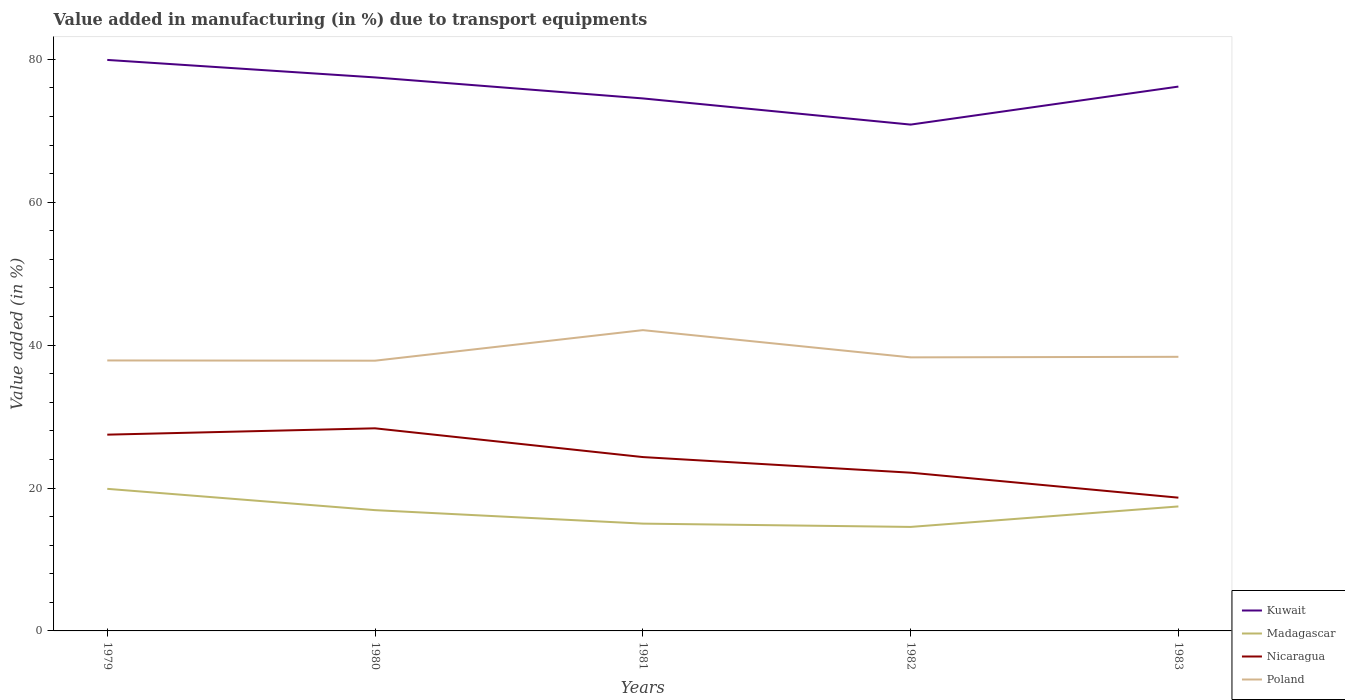How many different coloured lines are there?
Your response must be concise. 4. Across all years, what is the maximum percentage of value added in manufacturing due to transport equipments in Madagascar?
Provide a succinct answer. 14.55. In which year was the percentage of value added in manufacturing due to transport equipments in Kuwait maximum?
Keep it short and to the point. 1982. What is the total percentage of value added in manufacturing due to transport equipments in Poland in the graph?
Give a very brief answer. -0.08. What is the difference between the highest and the second highest percentage of value added in manufacturing due to transport equipments in Poland?
Make the answer very short. 4.28. How many lines are there?
Your answer should be very brief. 4. Are the values on the major ticks of Y-axis written in scientific E-notation?
Provide a short and direct response. No. Does the graph contain any zero values?
Ensure brevity in your answer.  No. Does the graph contain grids?
Make the answer very short. No. How many legend labels are there?
Your answer should be very brief. 4. What is the title of the graph?
Your response must be concise. Value added in manufacturing (in %) due to transport equipments. What is the label or title of the Y-axis?
Your answer should be compact. Value added (in %). What is the Value added (in %) in Kuwait in 1979?
Offer a very short reply. 79.91. What is the Value added (in %) in Madagascar in 1979?
Your answer should be compact. 19.88. What is the Value added (in %) of Nicaragua in 1979?
Provide a succinct answer. 27.47. What is the Value added (in %) in Poland in 1979?
Provide a succinct answer. 37.85. What is the Value added (in %) in Kuwait in 1980?
Provide a succinct answer. 77.46. What is the Value added (in %) in Madagascar in 1980?
Make the answer very short. 16.9. What is the Value added (in %) of Nicaragua in 1980?
Give a very brief answer. 28.35. What is the Value added (in %) of Poland in 1980?
Provide a short and direct response. 37.82. What is the Value added (in %) in Kuwait in 1981?
Your answer should be very brief. 74.52. What is the Value added (in %) of Madagascar in 1981?
Give a very brief answer. 15.01. What is the Value added (in %) in Nicaragua in 1981?
Provide a succinct answer. 24.33. What is the Value added (in %) in Poland in 1981?
Your answer should be very brief. 42.09. What is the Value added (in %) of Kuwait in 1982?
Your answer should be compact. 70.86. What is the Value added (in %) in Madagascar in 1982?
Your response must be concise. 14.55. What is the Value added (in %) in Nicaragua in 1982?
Offer a very short reply. 22.14. What is the Value added (in %) in Poland in 1982?
Make the answer very short. 38.28. What is the Value added (in %) in Kuwait in 1983?
Make the answer very short. 76.18. What is the Value added (in %) in Madagascar in 1983?
Offer a terse response. 17.42. What is the Value added (in %) in Nicaragua in 1983?
Provide a succinct answer. 18.65. What is the Value added (in %) of Poland in 1983?
Give a very brief answer. 38.36. Across all years, what is the maximum Value added (in %) of Kuwait?
Keep it short and to the point. 79.91. Across all years, what is the maximum Value added (in %) of Madagascar?
Your answer should be very brief. 19.88. Across all years, what is the maximum Value added (in %) in Nicaragua?
Your answer should be very brief. 28.35. Across all years, what is the maximum Value added (in %) in Poland?
Your response must be concise. 42.09. Across all years, what is the minimum Value added (in %) in Kuwait?
Your response must be concise. 70.86. Across all years, what is the minimum Value added (in %) of Madagascar?
Give a very brief answer. 14.55. Across all years, what is the minimum Value added (in %) of Nicaragua?
Offer a terse response. 18.65. Across all years, what is the minimum Value added (in %) in Poland?
Keep it short and to the point. 37.82. What is the total Value added (in %) of Kuwait in the graph?
Offer a terse response. 378.92. What is the total Value added (in %) in Madagascar in the graph?
Provide a short and direct response. 83.78. What is the total Value added (in %) in Nicaragua in the graph?
Your response must be concise. 120.94. What is the total Value added (in %) in Poland in the graph?
Keep it short and to the point. 194.4. What is the difference between the Value added (in %) in Kuwait in 1979 and that in 1980?
Provide a succinct answer. 2.45. What is the difference between the Value added (in %) in Madagascar in 1979 and that in 1980?
Give a very brief answer. 2.98. What is the difference between the Value added (in %) of Nicaragua in 1979 and that in 1980?
Ensure brevity in your answer.  -0.89. What is the difference between the Value added (in %) in Poland in 1979 and that in 1980?
Your answer should be very brief. 0.03. What is the difference between the Value added (in %) in Kuwait in 1979 and that in 1981?
Your answer should be very brief. 5.39. What is the difference between the Value added (in %) in Madagascar in 1979 and that in 1981?
Provide a succinct answer. 4.87. What is the difference between the Value added (in %) of Nicaragua in 1979 and that in 1981?
Your answer should be very brief. 3.14. What is the difference between the Value added (in %) of Poland in 1979 and that in 1981?
Ensure brevity in your answer.  -4.24. What is the difference between the Value added (in %) in Kuwait in 1979 and that in 1982?
Your response must be concise. 9.05. What is the difference between the Value added (in %) of Madagascar in 1979 and that in 1982?
Ensure brevity in your answer.  5.33. What is the difference between the Value added (in %) in Nicaragua in 1979 and that in 1982?
Give a very brief answer. 5.32. What is the difference between the Value added (in %) in Poland in 1979 and that in 1982?
Your response must be concise. -0.43. What is the difference between the Value added (in %) of Kuwait in 1979 and that in 1983?
Offer a terse response. 3.73. What is the difference between the Value added (in %) in Madagascar in 1979 and that in 1983?
Your answer should be very brief. 2.46. What is the difference between the Value added (in %) in Nicaragua in 1979 and that in 1983?
Your answer should be compact. 8.82. What is the difference between the Value added (in %) of Poland in 1979 and that in 1983?
Your answer should be compact. -0.51. What is the difference between the Value added (in %) in Kuwait in 1980 and that in 1981?
Your answer should be very brief. 2.94. What is the difference between the Value added (in %) of Madagascar in 1980 and that in 1981?
Keep it short and to the point. 1.89. What is the difference between the Value added (in %) in Nicaragua in 1980 and that in 1981?
Your answer should be compact. 4.02. What is the difference between the Value added (in %) of Poland in 1980 and that in 1981?
Offer a very short reply. -4.28. What is the difference between the Value added (in %) of Kuwait in 1980 and that in 1982?
Your answer should be very brief. 6.6. What is the difference between the Value added (in %) in Madagascar in 1980 and that in 1982?
Your response must be concise. 2.35. What is the difference between the Value added (in %) in Nicaragua in 1980 and that in 1982?
Offer a very short reply. 6.21. What is the difference between the Value added (in %) in Poland in 1980 and that in 1982?
Keep it short and to the point. -0.47. What is the difference between the Value added (in %) in Kuwait in 1980 and that in 1983?
Offer a terse response. 1.28. What is the difference between the Value added (in %) in Madagascar in 1980 and that in 1983?
Your response must be concise. -0.52. What is the difference between the Value added (in %) in Nicaragua in 1980 and that in 1983?
Your answer should be compact. 9.7. What is the difference between the Value added (in %) in Poland in 1980 and that in 1983?
Ensure brevity in your answer.  -0.54. What is the difference between the Value added (in %) of Kuwait in 1981 and that in 1982?
Offer a terse response. 3.66. What is the difference between the Value added (in %) in Madagascar in 1981 and that in 1982?
Your response must be concise. 0.46. What is the difference between the Value added (in %) in Nicaragua in 1981 and that in 1982?
Provide a succinct answer. 2.19. What is the difference between the Value added (in %) in Poland in 1981 and that in 1982?
Ensure brevity in your answer.  3.81. What is the difference between the Value added (in %) in Kuwait in 1981 and that in 1983?
Your response must be concise. -1.66. What is the difference between the Value added (in %) in Madagascar in 1981 and that in 1983?
Offer a very short reply. -2.41. What is the difference between the Value added (in %) in Nicaragua in 1981 and that in 1983?
Offer a terse response. 5.68. What is the difference between the Value added (in %) of Poland in 1981 and that in 1983?
Your answer should be very brief. 3.73. What is the difference between the Value added (in %) of Kuwait in 1982 and that in 1983?
Offer a very short reply. -5.32. What is the difference between the Value added (in %) of Madagascar in 1982 and that in 1983?
Your answer should be compact. -2.87. What is the difference between the Value added (in %) in Nicaragua in 1982 and that in 1983?
Keep it short and to the point. 3.5. What is the difference between the Value added (in %) of Poland in 1982 and that in 1983?
Make the answer very short. -0.08. What is the difference between the Value added (in %) of Kuwait in 1979 and the Value added (in %) of Madagascar in 1980?
Provide a succinct answer. 63. What is the difference between the Value added (in %) in Kuwait in 1979 and the Value added (in %) in Nicaragua in 1980?
Give a very brief answer. 51.55. What is the difference between the Value added (in %) of Kuwait in 1979 and the Value added (in %) of Poland in 1980?
Give a very brief answer. 42.09. What is the difference between the Value added (in %) of Madagascar in 1979 and the Value added (in %) of Nicaragua in 1980?
Keep it short and to the point. -8.47. What is the difference between the Value added (in %) in Madagascar in 1979 and the Value added (in %) in Poland in 1980?
Your answer should be very brief. -17.93. What is the difference between the Value added (in %) of Nicaragua in 1979 and the Value added (in %) of Poland in 1980?
Offer a very short reply. -10.35. What is the difference between the Value added (in %) of Kuwait in 1979 and the Value added (in %) of Madagascar in 1981?
Your response must be concise. 64.89. What is the difference between the Value added (in %) in Kuwait in 1979 and the Value added (in %) in Nicaragua in 1981?
Provide a short and direct response. 55.58. What is the difference between the Value added (in %) in Kuwait in 1979 and the Value added (in %) in Poland in 1981?
Provide a succinct answer. 37.81. What is the difference between the Value added (in %) of Madagascar in 1979 and the Value added (in %) of Nicaragua in 1981?
Offer a terse response. -4.45. What is the difference between the Value added (in %) in Madagascar in 1979 and the Value added (in %) in Poland in 1981?
Offer a very short reply. -22.21. What is the difference between the Value added (in %) of Nicaragua in 1979 and the Value added (in %) of Poland in 1981?
Keep it short and to the point. -14.63. What is the difference between the Value added (in %) of Kuwait in 1979 and the Value added (in %) of Madagascar in 1982?
Make the answer very short. 65.35. What is the difference between the Value added (in %) of Kuwait in 1979 and the Value added (in %) of Nicaragua in 1982?
Provide a short and direct response. 57.76. What is the difference between the Value added (in %) of Kuwait in 1979 and the Value added (in %) of Poland in 1982?
Your answer should be compact. 41.62. What is the difference between the Value added (in %) of Madagascar in 1979 and the Value added (in %) of Nicaragua in 1982?
Your answer should be very brief. -2.26. What is the difference between the Value added (in %) in Madagascar in 1979 and the Value added (in %) in Poland in 1982?
Offer a terse response. -18.4. What is the difference between the Value added (in %) of Nicaragua in 1979 and the Value added (in %) of Poland in 1982?
Give a very brief answer. -10.82. What is the difference between the Value added (in %) in Kuwait in 1979 and the Value added (in %) in Madagascar in 1983?
Your answer should be very brief. 62.49. What is the difference between the Value added (in %) of Kuwait in 1979 and the Value added (in %) of Nicaragua in 1983?
Your answer should be very brief. 61.26. What is the difference between the Value added (in %) of Kuwait in 1979 and the Value added (in %) of Poland in 1983?
Make the answer very short. 41.55. What is the difference between the Value added (in %) of Madagascar in 1979 and the Value added (in %) of Nicaragua in 1983?
Your answer should be very brief. 1.23. What is the difference between the Value added (in %) of Madagascar in 1979 and the Value added (in %) of Poland in 1983?
Make the answer very short. -18.48. What is the difference between the Value added (in %) of Nicaragua in 1979 and the Value added (in %) of Poland in 1983?
Provide a succinct answer. -10.89. What is the difference between the Value added (in %) in Kuwait in 1980 and the Value added (in %) in Madagascar in 1981?
Your answer should be compact. 62.44. What is the difference between the Value added (in %) in Kuwait in 1980 and the Value added (in %) in Nicaragua in 1981?
Offer a terse response. 53.13. What is the difference between the Value added (in %) in Kuwait in 1980 and the Value added (in %) in Poland in 1981?
Keep it short and to the point. 35.37. What is the difference between the Value added (in %) in Madagascar in 1980 and the Value added (in %) in Nicaragua in 1981?
Provide a short and direct response. -7.43. What is the difference between the Value added (in %) in Madagascar in 1980 and the Value added (in %) in Poland in 1981?
Provide a succinct answer. -25.19. What is the difference between the Value added (in %) of Nicaragua in 1980 and the Value added (in %) of Poland in 1981?
Make the answer very short. -13.74. What is the difference between the Value added (in %) of Kuwait in 1980 and the Value added (in %) of Madagascar in 1982?
Your answer should be very brief. 62.9. What is the difference between the Value added (in %) in Kuwait in 1980 and the Value added (in %) in Nicaragua in 1982?
Keep it short and to the point. 55.31. What is the difference between the Value added (in %) of Kuwait in 1980 and the Value added (in %) of Poland in 1982?
Give a very brief answer. 39.18. What is the difference between the Value added (in %) in Madagascar in 1980 and the Value added (in %) in Nicaragua in 1982?
Provide a succinct answer. -5.24. What is the difference between the Value added (in %) of Madagascar in 1980 and the Value added (in %) of Poland in 1982?
Ensure brevity in your answer.  -21.38. What is the difference between the Value added (in %) of Nicaragua in 1980 and the Value added (in %) of Poland in 1982?
Your response must be concise. -9.93. What is the difference between the Value added (in %) in Kuwait in 1980 and the Value added (in %) in Madagascar in 1983?
Your answer should be compact. 60.04. What is the difference between the Value added (in %) in Kuwait in 1980 and the Value added (in %) in Nicaragua in 1983?
Ensure brevity in your answer.  58.81. What is the difference between the Value added (in %) of Kuwait in 1980 and the Value added (in %) of Poland in 1983?
Provide a short and direct response. 39.1. What is the difference between the Value added (in %) in Madagascar in 1980 and the Value added (in %) in Nicaragua in 1983?
Ensure brevity in your answer.  -1.75. What is the difference between the Value added (in %) in Madagascar in 1980 and the Value added (in %) in Poland in 1983?
Offer a terse response. -21.46. What is the difference between the Value added (in %) of Nicaragua in 1980 and the Value added (in %) of Poland in 1983?
Offer a very short reply. -10.01. What is the difference between the Value added (in %) of Kuwait in 1981 and the Value added (in %) of Madagascar in 1982?
Make the answer very short. 59.96. What is the difference between the Value added (in %) of Kuwait in 1981 and the Value added (in %) of Nicaragua in 1982?
Your answer should be compact. 52.37. What is the difference between the Value added (in %) in Kuwait in 1981 and the Value added (in %) in Poland in 1982?
Provide a succinct answer. 36.24. What is the difference between the Value added (in %) of Madagascar in 1981 and the Value added (in %) of Nicaragua in 1982?
Provide a succinct answer. -7.13. What is the difference between the Value added (in %) in Madagascar in 1981 and the Value added (in %) in Poland in 1982?
Keep it short and to the point. -23.27. What is the difference between the Value added (in %) of Nicaragua in 1981 and the Value added (in %) of Poland in 1982?
Give a very brief answer. -13.95. What is the difference between the Value added (in %) in Kuwait in 1981 and the Value added (in %) in Madagascar in 1983?
Provide a succinct answer. 57.1. What is the difference between the Value added (in %) in Kuwait in 1981 and the Value added (in %) in Nicaragua in 1983?
Offer a very short reply. 55.87. What is the difference between the Value added (in %) in Kuwait in 1981 and the Value added (in %) in Poland in 1983?
Keep it short and to the point. 36.16. What is the difference between the Value added (in %) in Madagascar in 1981 and the Value added (in %) in Nicaragua in 1983?
Offer a terse response. -3.63. What is the difference between the Value added (in %) of Madagascar in 1981 and the Value added (in %) of Poland in 1983?
Ensure brevity in your answer.  -23.35. What is the difference between the Value added (in %) in Nicaragua in 1981 and the Value added (in %) in Poland in 1983?
Your response must be concise. -14.03. What is the difference between the Value added (in %) in Kuwait in 1982 and the Value added (in %) in Madagascar in 1983?
Your response must be concise. 53.44. What is the difference between the Value added (in %) in Kuwait in 1982 and the Value added (in %) in Nicaragua in 1983?
Give a very brief answer. 52.21. What is the difference between the Value added (in %) in Kuwait in 1982 and the Value added (in %) in Poland in 1983?
Give a very brief answer. 32.5. What is the difference between the Value added (in %) of Madagascar in 1982 and the Value added (in %) of Nicaragua in 1983?
Offer a very short reply. -4.09. What is the difference between the Value added (in %) of Madagascar in 1982 and the Value added (in %) of Poland in 1983?
Offer a very short reply. -23.81. What is the difference between the Value added (in %) in Nicaragua in 1982 and the Value added (in %) in Poland in 1983?
Provide a short and direct response. -16.22. What is the average Value added (in %) of Kuwait per year?
Offer a very short reply. 75.78. What is the average Value added (in %) in Madagascar per year?
Provide a short and direct response. 16.76. What is the average Value added (in %) in Nicaragua per year?
Your response must be concise. 24.19. What is the average Value added (in %) of Poland per year?
Give a very brief answer. 38.88. In the year 1979, what is the difference between the Value added (in %) of Kuwait and Value added (in %) of Madagascar?
Ensure brevity in your answer.  60.02. In the year 1979, what is the difference between the Value added (in %) of Kuwait and Value added (in %) of Nicaragua?
Give a very brief answer. 52.44. In the year 1979, what is the difference between the Value added (in %) in Kuwait and Value added (in %) in Poland?
Your response must be concise. 42.06. In the year 1979, what is the difference between the Value added (in %) of Madagascar and Value added (in %) of Nicaragua?
Keep it short and to the point. -7.58. In the year 1979, what is the difference between the Value added (in %) in Madagascar and Value added (in %) in Poland?
Ensure brevity in your answer.  -17.97. In the year 1979, what is the difference between the Value added (in %) of Nicaragua and Value added (in %) of Poland?
Your answer should be very brief. -10.38. In the year 1980, what is the difference between the Value added (in %) of Kuwait and Value added (in %) of Madagascar?
Your answer should be very brief. 60.56. In the year 1980, what is the difference between the Value added (in %) in Kuwait and Value added (in %) in Nicaragua?
Offer a terse response. 49.11. In the year 1980, what is the difference between the Value added (in %) in Kuwait and Value added (in %) in Poland?
Provide a short and direct response. 39.64. In the year 1980, what is the difference between the Value added (in %) in Madagascar and Value added (in %) in Nicaragua?
Your answer should be compact. -11.45. In the year 1980, what is the difference between the Value added (in %) in Madagascar and Value added (in %) in Poland?
Your answer should be compact. -20.91. In the year 1980, what is the difference between the Value added (in %) of Nicaragua and Value added (in %) of Poland?
Provide a short and direct response. -9.46. In the year 1981, what is the difference between the Value added (in %) of Kuwait and Value added (in %) of Madagascar?
Keep it short and to the point. 59.5. In the year 1981, what is the difference between the Value added (in %) in Kuwait and Value added (in %) in Nicaragua?
Offer a very short reply. 50.19. In the year 1981, what is the difference between the Value added (in %) of Kuwait and Value added (in %) of Poland?
Your response must be concise. 32.43. In the year 1981, what is the difference between the Value added (in %) of Madagascar and Value added (in %) of Nicaragua?
Give a very brief answer. -9.31. In the year 1981, what is the difference between the Value added (in %) of Madagascar and Value added (in %) of Poland?
Make the answer very short. -27.08. In the year 1981, what is the difference between the Value added (in %) of Nicaragua and Value added (in %) of Poland?
Keep it short and to the point. -17.76. In the year 1982, what is the difference between the Value added (in %) of Kuwait and Value added (in %) of Madagascar?
Provide a short and direct response. 56.3. In the year 1982, what is the difference between the Value added (in %) in Kuwait and Value added (in %) in Nicaragua?
Ensure brevity in your answer.  48.71. In the year 1982, what is the difference between the Value added (in %) of Kuwait and Value added (in %) of Poland?
Make the answer very short. 32.57. In the year 1982, what is the difference between the Value added (in %) in Madagascar and Value added (in %) in Nicaragua?
Your answer should be very brief. -7.59. In the year 1982, what is the difference between the Value added (in %) in Madagascar and Value added (in %) in Poland?
Provide a short and direct response. -23.73. In the year 1982, what is the difference between the Value added (in %) in Nicaragua and Value added (in %) in Poland?
Ensure brevity in your answer.  -16.14. In the year 1983, what is the difference between the Value added (in %) in Kuwait and Value added (in %) in Madagascar?
Keep it short and to the point. 58.76. In the year 1983, what is the difference between the Value added (in %) in Kuwait and Value added (in %) in Nicaragua?
Ensure brevity in your answer.  57.53. In the year 1983, what is the difference between the Value added (in %) of Kuwait and Value added (in %) of Poland?
Make the answer very short. 37.82. In the year 1983, what is the difference between the Value added (in %) in Madagascar and Value added (in %) in Nicaragua?
Your answer should be compact. -1.23. In the year 1983, what is the difference between the Value added (in %) in Madagascar and Value added (in %) in Poland?
Make the answer very short. -20.94. In the year 1983, what is the difference between the Value added (in %) of Nicaragua and Value added (in %) of Poland?
Offer a terse response. -19.71. What is the ratio of the Value added (in %) of Kuwait in 1979 to that in 1980?
Keep it short and to the point. 1.03. What is the ratio of the Value added (in %) in Madagascar in 1979 to that in 1980?
Ensure brevity in your answer.  1.18. What is the ratio of the Value added (in %) in Nicaragua in 1979 to that in 1980?
Ensure brevity in your answer.  0.97. What is the ratio of the Value added (in %) of Kuwait in 1979 to that in 1981?
Offer a terse response. 1.07. What is the ratio of the Value added (in %) in Madagascar in 1979 to that in 1981?
Offer a terse response. 1.32. What is the ratio of the Value added (in %) in Nicaragua in 1979 to that in 1981?
Your answer should be compact. 1.13. What is the ratio of the Value added (in %) of Poland in 1979 to that in 1981?
Your answer should be very brief. 0.9. What is the ratio of the Value added (in %) in Kuwait in 1979 to that in 1982?
Offer a terse response. 1.13. What is the ratio of the Value added (in %) in Madagascar in 1979 to that in 1982?
Give a very brief answer. 1.37. What is the ratio of the Value added (in %) of Nicaragua in 1979 to that in 1982?
Offer a terse response. 1.24. What is the ratio of the Value added (in %) of Poland in 1979 to that in 1982?
Make the answer very short. 0.99. What is the ratio of the Value added (in %) of Kuwait in 1979 to that in 1983?
Offer a very short reply. 1.05. What is the ratio of the Value added (in %) in Madagascar in 1979 to that in 1983?
Ensure brevity in your answer.  1.14. What is the ratio of the Value added (in %) in Nicaragua in 1979 to that in 1983?
Keep it short and to the point. 1.47. What is the ratio of the Value added (in %) in Poland in 1979 to that in 1983?
Ensure brevity in your answer.  0.99. What is the ratio of the Value added (in %) in Kuwait in 1980 to that in 1981?
Give a very brief answer. 1.04. What is the ratio of the Value added (in %) of Madagascar in 1980 to that in 1981?
Provide a short and direct response. 1.13. What is the ratio of the Value added (in %) in Nicaragua in 1980 to that in 1981?
Offer a very short reply. 1.17. What is the ratio of the Value added (in %) of Poland in 1980 to that in 1981?
Offer a terse response. 0.9. What is the ratio of the Value added (in %) in Kuwait in 1980 to that in 1982?
Provide a short and direct response. 1.09. What is the ratio of the Value added (in %) of Madagascar in 1980 to that in 1982?
Make the answer very short. 1.16. What is the ratio of the Value added (in %) of Nicaragua in 1980 to that in 1982?
Your answer should be very brief. 1.28. What is the ratio of the Value added (in %) of Kuwait in 1980 to that in 1983?
Offer a terse response. 1.02. What is the ratio of the Value added (in %) in Madagascar in 1980 to that in 1983?
Offer a terse response. 0.97. What is the ratio of the Value added (in %) in Nicaragua in 1980 to that in 1983?
Your answer should be compact. 1.52. What is the ratio of the Value added (in %) in Poland in 1980 to that in 1983?
Your response must be concise. 0.99. What is the ratio of the Value added (in %) of Kuwait in 1981 to that in 1982?
Ensure brevity in your answer.  1.05. What is the ratio of the Value added (in %) in Madagascar in 1981 to that in 1982?
Provide a short and direct response. 1.03. What is the ratio of the Value added (in %) of Nicaragua in 1981 to that in 1982?
Offer a terse response. 1.1. What is the ratio of the Value added (in %) in Poland in 1981 to that in 1982?
Make the answer very short. 1.1. What is the ratio of the Value added (in %) in Kuwait in 1981 to that in 1983?
Offer a terse response. 0.98. What is the ratio of the Value added (in %) of Madagascar in 1981 to that in 1983?
Offer a very short reply. 0.86. What is the ratio of the Value added (in %) in Nicaragua in 1981 to that in 1983?
Offer a terse response. 1.3. What is the ratio of the Value added (in %) in Poland in 1981 to that in 1983?
Offer a terse response. 1.1. What is the ratio of the Value added (in %) of Kuwait in 1982 to that in 1983?
Keep it short and to the point. 0.93. What is the ratio of the Value added (in %) in Madagascar in 1982 to that in 1983?
Your answer should be very brief. 0.84. What is the ratio of the Value added (in %) in Nicaragua in 1982 to that in 1983?
Your answer should be very brief. 1.19. What is the ratio of the Value added (in %) in Poland in 1982 to that in 1983?
Your response must be concise. 1. What is the difference between the highest and the second highest Value added (in %) of Kuwait?
Offer a terse response. 2.45. What is the difference between the highest and the second highest Value added (in %) of Madagascar?
Give a very brief answer. 2.46. What is the difference between the highest and the second highest Value added (in %) of Nicaragua?
Give a very brief answer. 0.89. What is the difference between the highest and the second highest Value added (in %) of Poland?
Offer a terse response. 3.73. What is the difference between the highest and the lowest Value added (in %) in Kuwait?
Offer a terse response. 9.05. What is the difference between the highest and the lowest Value added (in %) in Madagascar?
Offer a terse response. 5.33. What is the difference between the highest and the lowest Value added (in %) in Nicaragua?
Your answer should be compact. 9.7. What is the difference between the highest and the lowest Value added (in %) in Poland?
Keep it short and to the point. 4.28. 